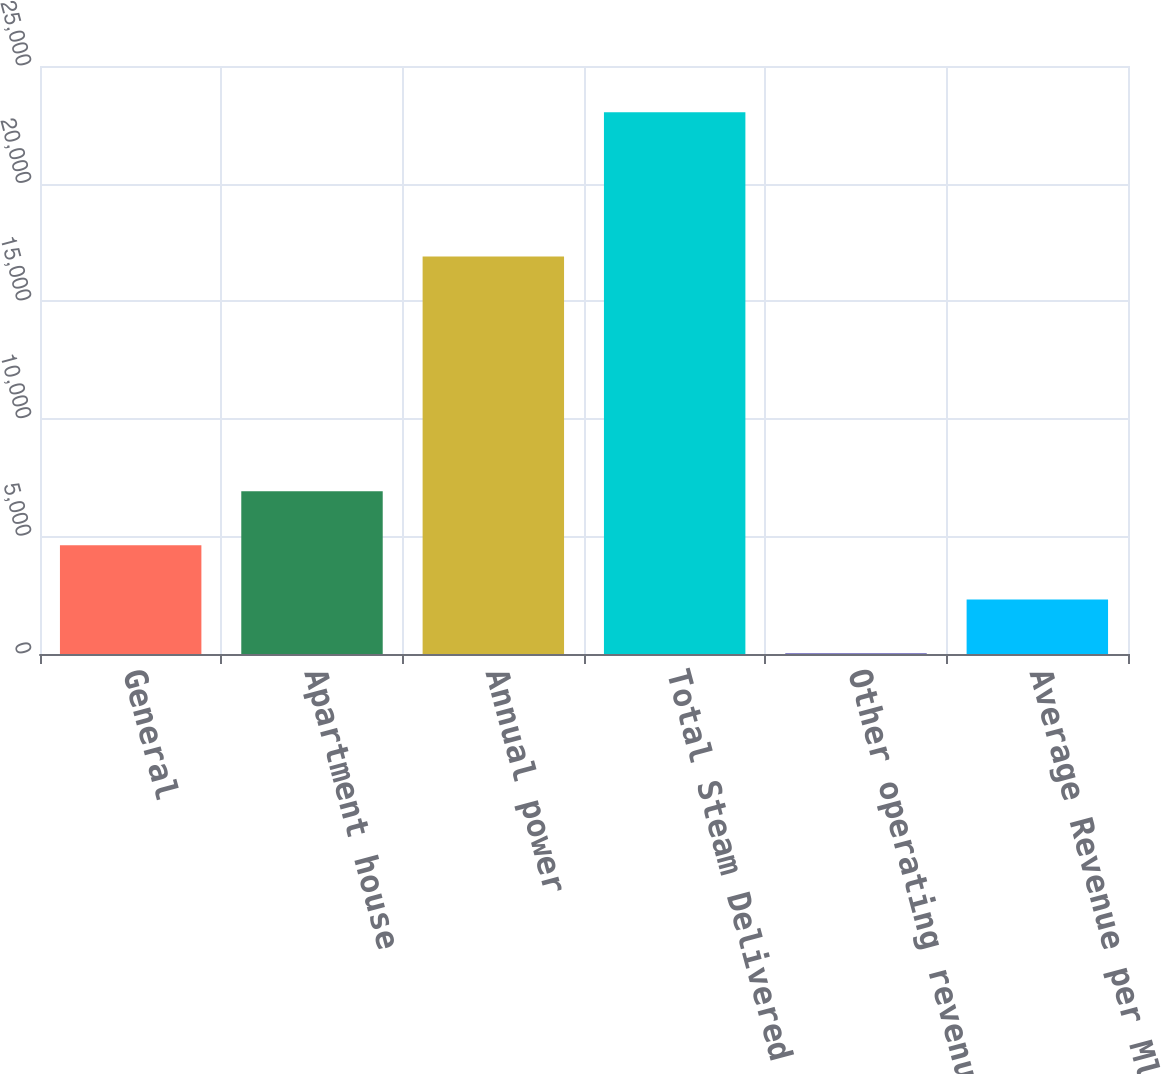Convert chart. <chart><loc_0><loc_0><loc_500><loc_500><bar_chart><fcel>General<fcel>Apartment house<fcel>Annual power<fcel>Total Steam Delivered to<fcel>Other operating revenues<fcel>Average Revenue per Mlb Sold<nl><fcel>4618.8<fcel>6920.2<fcel>16903<fcel>23030<fcel>16<fcel>2317.4<nl></chart> 